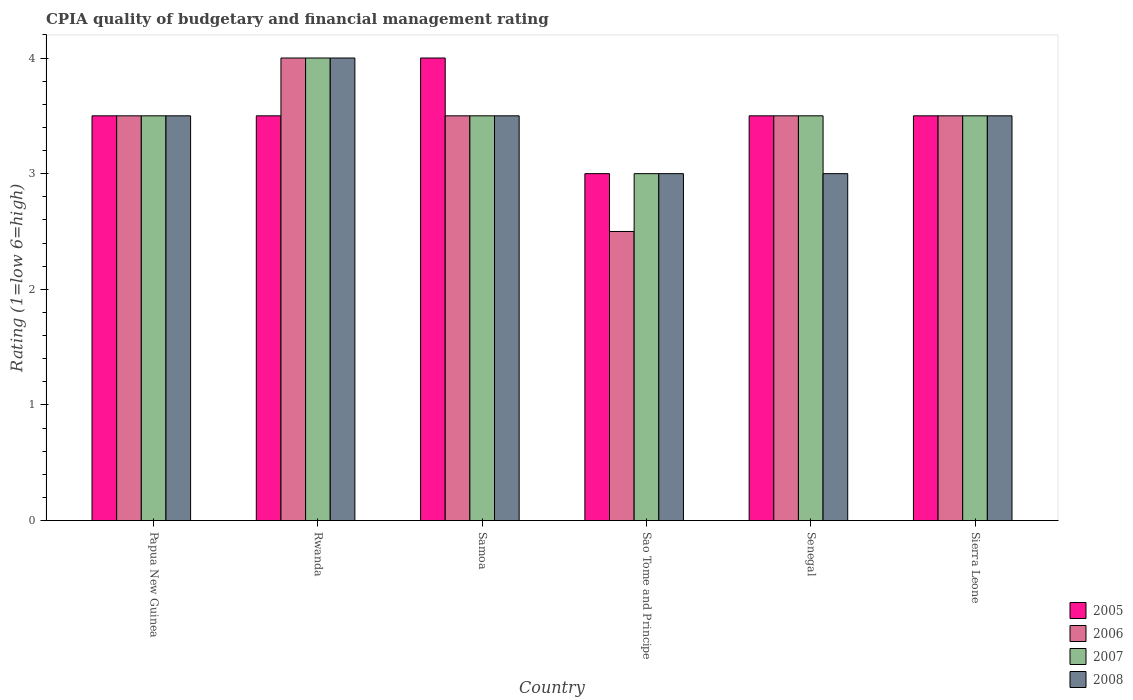How many groups of bars are there?
Offer a very short reply. 6. How many bars are there on the 3rd tick from the left?
Keep it short and to the point. 4. How many bars are there on the 6th tick from the right?
Your answer should be very brief. 4. What is the label of the 1st group of bars from the left?
Your answer should be very brief. Papua New Guinea. What is the CPIA rating in 2007 in Senegal?
Make the answer very short. 3.5. Across all countries, what is the minimum CPIA rating in 2008?
Offer a terse response. 3. In which country was the CPIA rating in 2007 maximum?
Ensure brevity in your answer.  Rwanda. In which country was the CPIA rating in 2006 minimum?
Provide a succinct answer. Sao Tome and Principe. In how many countries, is the CPIA rating in 2005 greater than 2.8?
Your answer should be compact. 6. What is the ratio of the CPIA rating in 2008 in Papua New Guinea to that in Samoa?
Make the answer very short. 1. Is the CPIA rating in 2005 in Papua New Guinea less than that in Senegal?
Provide a short and direct response. No. Is the difference between the CPIA rating in 2005 in Samoa and Sao Tome and Principe greater than the difference between the CPIA rating in 2007 in Samoa and Sao Tome and Principe?
Your answer should be compact. Yes. In how many countries, is the CPIA rating in 2005 greater than the average CPIA rating in 2005 taken over all countries?
Your answer should be compact. 1. Is it the case that in every country, the sum of the CPIA rating in 2006 and CPIA rating in 2005 is greater than the sum of CPIA rating in 2008 and CPIA rating in 2007?
Ensure brevity in your answer.  No. How many bars are there?
Make the answer very short. 24. How many countries are there in the graph?
Give a very brief answer. 6. What is the difference between two consecutive major ticks on the Y-axis?
Your response must be concise. 1. Does the graph contain grids?
Make the answer very short. No. How many legend labels are there?
Offer a very short reply. 4. How are the legend labels stacked?
Make the answer very short. Vertical. What is the title of the graph?
Make the answer very short. CPIA quality of budgetary and financial management rating. What is the label or title of the X-axis?
Your response must be concise. Country. What is the Rating (1=low 6=high) of 2005 in Papua New Guinea?
Your answer should be very brief. 3.5. What is the Rating (1=low 6=high) of 2006 in Papua New Guinea?
Give a very brief answer. 3.5. What is the Rating (1=low 6=high) in 2007 in Papua New Guinea?
Provide a short and direct response. 3.5. What is the Rating (1=low 6=high) in 2007 in Rwanda?
Your response must be concise. 4. What is the Rating (1=low 6=high) of 2008 in Rwanda?
Keep it short and to the point. 4. What is the Rating (1=low 6=high) in 2006 in Samoa?
Make the answer very short. 3.5. What is the Rating (1=low 6=high) in 2007 in Samoa?
Your answer should be compact. 3.5. What is the Rating (1=low 6=high) in 2008 in Samoa?
Make the answer very short. 3.5. What is the Rating (1=low 6=high) of 2005 in Sao Tome and Principe?
Your answer should be compact. 3. What is the Rating (1=low 6=high) in 2006 in Sao Tome and Principe?
Offer a very short reply. 2.5. What is the Rating (1=low 6=high) of 2008 in Sao Tome and Principe?
Your response must be concise. 3. What is the Rating (1=low 6=high) in 2007 in Senegal?
Your response must be concise. 3.5. What is the Rating (1=low 6=high) in 2008 in Senegal?
Provide a succinct answer. 3. What is the Rating (1=low 6=high) of 2007 in Sierra Leone?
Offer a very short reply. 3.5. What is the Rating (1=low 6=high) in 2008 in Sierra Leone?
Offer a terse response. 3.5. Across all countries, what is the maximum Rating (1=low 6=high) in 2005?
Your answer should be compact. 4. Across all countries, what is the maximum Rating (1=low 6=high) of 2006?
Your answer should be very brief. 4. Across all countries, what is the maximum Rating (1=low 6=high) in 2008?
Offer a very short reply. 4. Across all countries, what is the minimum Rating (1=low 6=high) of 2007?
Your response must be concise. 3. What is the total Rating (1=low 6=high) in 2006 in the graph?
Your answer should be very brief. 20.5. What is the difference between the Rating (1=low 6=high) in 2006 in Papua New Guinea and that in Rwanda?
Ensure brevity in your answer.  -0.5. What is the difference between the Rating (1=low 6=high) of 2008 in Papua New Guinea and that in Rwanda?
Keep it short and to the point. -0.5. What is the difference between the Rating (1=low 6=high) in 2008 in Papua New Guinea and that in Samoa?
Offer a terse response. 0. What is the difference between the Rating (1=low 6=high) in 2005 in Papua New Guinea and that in Sao Tome and Principe?
Your answer should be compact. 0.5. What is the difference between the Rating (1=low 6=high) in 2006 in Papua New Guinea and that in Sao Tome and Principe?
Your response must be concise. 1. What is the difference between the Rating (1=low 6=high) of 2007 in Papua New Guinea and that in Sao Tome and Principe?
Offer a very short reply. 0.5. What is the difference between the Rating (1=low 6=high) in 2008 in Papua New Guinea and that in Sao Tome and Principe?
Offer a very short reply. 0.5. What is the difference between the Rating (1=low 6=high) in 2007 in Papua New Guinea and that in Senegal?
Ensure brevity in your answer.  0. What is the difference between the Rating (1=low 6=high) in 2008 in Papua New Guinea and that in Senegal?
Your response must be concise. 0.5. What is the difference between the Rating (1=low 6=high) in 2006 in Papua New Guinea and that in Sierra Leone?
Your answer should be compact. 0. What is the difference between the Rating (1=low 6=high) of 2007 in Papua New Guinea and that in Sierra Leone?
Keep it short and to the point. 0. What is the difference between the Rating (1=low 6=high) in 2007 in Rwanda and that in Samoa?
Provide a succinct answer. 0.5. What is the difference between the Rating (1=low 6=high) of 2005 in Rwanda and that in Sao Tome and Principe?
Make the answer very short. 0.5. What is the difference between the Rating (1=low 6=high) in 2007 in Rwanda and that in Sao Tome and Principe?
Your answer should be compact. 1. What is the difference between the Rating (1=low 6=high) in 2008 in Rwanda and that in Sao Tome and Principe?
Your answer should be very brief. 1. What is the difference between the Rating (1=low 6=high) of 2006 in Rwanda and that in Senegal?
Make the answer very short. 0.5. What is the difference between the Rating (1=low 6=high) of 2007 in Rwanda and that in Senegal?
Keep it short and to the point. 0.5. What is the difference between the Rating (1=low 6=high) in 2006 in Rwanda and that in Sierra Leone?
Your answer should be very brief. 0.5. What is the difference between the Rating (1=low 6=high) in 2007 in Rwanda and that in Sierra Leone?
Your answer should be compact. 0.5. What is the difference between the Rating (1=low 6=high) in 2008 in Rwanda and that in Sierra Leone?
Your answer should be very brief. 0.5. What is the difference between the Rating (1=low 6=high) of 2005 in Samoa and that in Sao Tome and Principe?
Offer a terse response. 1. What is the difference between the Rating (1=low 6=high) of 2008 in Samoa and that in Sao Tome and Principe?
Your answer should be compact. 0.5. What is the difference between the Rating (1=low 6=high) in 2006 in Samoa and that in Senegal?
Your response must be concise. 0. What is the difference between the Rating (1=low 6=high) in 2007 in Samoa and that in Senegal?
Your answer should be very brief. 0. What is the difference between the Rating (1=low 6=high) of 2005 in Samoa and that in Sierra Leone?
Make the answer very short. 0.5. What is the difference between the Rating (1=low 6=high) of 2006 in Samoa and that in Sierra Leone?
Ensure brevity in your answer.  0. What is the difference between the Rating (1=low 6=high) in 2007 in Samoa and that in Sierra Leone?
Provide a short and direct response. 0. What is the difference between the Rating (1=low 6=high) of 2008 in Samoa and that in Sierra Leone?
Keep it short and to the point. 0. What is the difference between the Rating (1=low 6=high) in 2005 in Sao Tome and Principe and that in Senegal?
Keep it short and to the point. -0.5. What is the difference between the Rating (1=low 6=high) of 2008 in Sao Tome and Principe and that in Senegal?
Give a very brief answer. 0. What is the difference between the Rating (1=low 6=high) of 2006 in Sao Tome and Principe and that in Sierra Leone?
Your response must be concise. -1. What is the difference between the Rating (1=low 6=high) in 2008 in Sao Tome and Principe and that in Sierra Leone?
Offer a very short reply. -0.5. What is the difference between the Rating (1=low 6=high) in 2005 in Papua New Guinea and the Rating (1=low 6=high) in 2006 in Rwanda?
Provide a succinct answer. -0.5. What is the difference between the Rating (1=low 6=high) of 2007 in Papua New Guinea and the Rating (1=low 6=high) of 2008 in Rwanda?
Give a very brief answer. -0.5. What is the difference between the Rating (1=low 6=high) of 2006 in Papua New Guinea and the Rating (1=low 6=high) of 2007 in Samoa?
Make the answer very short. 0. What is the difference between the Rating (1=low 6=high) in 2006 in Papua New Guinea and the Rating (1=low 6=high) in 2008 in Samoa?
Give a very brief answer. 0. What is the difference between the Rating (1=low 6=high) of 2005 in Papua New Guinea and the Rating (1=low 6=high) of 2007 in Sao Tome and Principe?
Your response must be concise. 0.5. What is the difference between the Rating (1=low 6=high) of 2005 in Papua New Guinea and the Rating (1=low 6=high) of 2008 in Sao Tome and Principe?
Offer a terse response. 0.5. What is the difference between the Rating (1=low 6=high) of 2006 in Papua New Guinea and the Rating (1=low 6=high) of 2007 in Sao Tome and Principe?
Give a very brief answer. 0.5. What is the difference between the Rating (1=low 6=high) of 2006 in Papua New Guinea and the Rating (1=low 6=high) of 2008 in Sao Tome and Principe?
Offer a terse response. 0.5. What is the difference between the Rating (1=low 6=high) in 2005 in Papua New Guinea and the Rating (1=low 6=high) in 2006 in Senegal?
Your answer should be very brief. 0. What is the difference between the Rating (1=low 6=high) in 2006 in Papua New Guinea and the Rating (1=low 6=high) in 2008 in Senegal?
Your answer should be compact. 0.5. What is the difference between the Rating (1=low 6=high) of 2007 in Papua New Guinea and the Rating (1=low 6=high) of 2008 in Senegal?
Offer a very short reply. 0.5. What is the difference between the Rating (1=low 6=high) in 2005 in Papua New Guinea and the Rating (1=low 6=high) in 2008 in Sierra Leone?
Your answer should be compact. 0. What is the difference between the Rating (1=low 6=high) in 2006 in Papua New Guinea and the Rating (1=low 6=high) in 2008 in Sierra Leone?
Give a very brief answer. 0. What is the difference between the Rating (1=low 6=high) in 2005 in Rwanda and the Rating (1=low 6=high) in 2006 in Samoa?
Keep it short and to the point. 0. What is the difference between the Rating (1=low 6=high) of 2005 in Rwanda and the Rating (1=low 6=high) of 2007 in Samoa?
Make the answer very short. 0. What is the difference between the Rating (1=low 6=high) in 2005 in Rwanda and the Rating (1=low 6=high) in 2008 in Samoa?
Keep it short and to the point. 0. What is the difference between the Rating (1=low 6=high) in 2006 in Rwanda and the Rating (1=low 6=high) in 2007 in Samoa?
Ensure brevity in your answer.  0.5. What is the difference between the Rating (1=low 6=high) in 2007 in Rwanda and the Rating (1=low 6=high) in 2008 in Samoa?
Your answer should be compact. 0.5. What is the difference between the Rating (1=low 6=high) of 2005 in Rwanda and the Rating (1=low 6=high) of 2007 in Sao Tome and Principe?
Your response must be concise. 0.5. What is the difference between the Rating (1=low 6=high) in 2006 in Rwanda and the Rating (1=low 6=high) in 2008 in Sao Tome and Principe?
Offer a very short reply. 1. What is the difference between the Rating (1=low 6=high) in 2005 in Rwanda and the Rating (1=low 6=high) in 2006 in Senegal?
Your answer should be very brief. 0. What is the difference between the Rating (1=low 6=high) of 2006 in Rwanda and the Rating (1=low 6=high) of 2007 in Senegal?
Your answer should be compact. 0.5. What is the difference between the Rating (1=low 6=high) in 2006 in Rwanda and the Rating (1=low 6=high) in 2008 in Senegal?
Your response must be concise. 1. What is the difference between the Rating (1=low 6=high) in 2005 in Rwanda and the Rating (1=low 6=high) in 2007 in Sierra Leone?
Your answer should be very brief. 0. What is the difference between the Rating (1=low 6=high) in 2005 in Samoa and the Rating (1=low 6=high) in 2007 in Sao Tome and Principe?
Your answer should be compact. 1. What is the difference between the Rating (1=low 6=high) in 2005 in Samoa and the Rating (1=low 6=high) in 2008 in Sao Tome and Principe?
Provide a short and direct response. 1. What is the difference between the Rating (1=low 6=high) in 2005 in Samoa and the Rating (1=low 6=high) in 2006 in Senegal?
Your answer should be very brief. 0.5. What is the difference between the Rating (1=low 6=high) of 2006 in Samoa and the Rating (1=low 6=high) of 2008 in Senegal?
Provide a succinct answer. 0.5. What is the difference between the Rating (1=low 6=high) in 2007 in Samoa and the Rating (1=low 6=high) in 2008 in Senegal?
Your answer should be very brief. 0.5. What is the difference between the Rating (1=low 6=high) in 2005 in Samoa and the Rating (1=low 6=high) in 2008 in Sierra Leone?
Your answer should be very brief. 0.5. What is the difference between the Rating (1=low 6=high) of 2006 in Samoa and the Rating (1=low 6=high) of 2008 in Sierra Leone?
Give a very brief answer. 0. What is the difference between the Rating (1=low 6=high) of 2005 in Sao Tome and Principe and the Rating (1=low 6=high) of 2006 in Senegal?
Provide a short and direct response. -0.5. What is the difference between the Rating (1=low 6=high) in 2005 in Sao Tome and Principe and the Rating (1=low 6=high) in 2007 in Senegal?
Your answer should be very brief. -0.5. What is the difference between the Rating (1=low 6=high) in 2006 in Sao Tome and Principe and the Rating (1=low 6=high) in 2007 in Senegal?
Ensure brevity in your answer.  -1. What is the difference between the Rating (1=low 6=high) in 2006 in Sao Tome and Principe and the Rating (1=low 6=high) in 2008 in Senegal?
Offer a terse response. -0.5. What is the difference between the Rating (1=low 6=high) of 2007 in Sao Tome and Principe and the Rating (1=low 6=high) of 2008 in Senegal?
Ensure brevity in your answer.  0. What is the difference between the Rating (1=low 6=high) of 2005 in Sao Tome and Principe and the Rating (1=low 6=high) of 2006 in Sierra Leone?
Make the answer very short. -0.5. What is the difference between the Rating (1=low 6=high) in 2006 in Sao Tome and Principe and the Rating (1=low 6=high) in 2007 in Sierra Leone?
Offer a terse response. -1. What is the difference between the Rating (1=low 6=high) in 2005 in Senegal and the Rating (1=low 6=high) in 2007 in Sierra Leone?
Ensure brevity in your answer.  0. What is the difference between the Rating (1=low 6=high) in 2006 in Senegal and the Rating (1=low 6=high) in 2007 in Sierra Leone?
Give a very brief answer. 0. What is the difference between the Rating (1=low 6=high) in 2006 in Senegal and the Rating (1=low 6=high) in 2008 in Sierra Leone?
Keep it short and to the point. 0. What is the difference between the Rating (1=low 6=high) in 2007 in Senegal and the Rating (1=low 6=high) in 2008 in Sierra Leone?
Offer a terse response. 0. What is the average Rating (1=low 6=high) of 2005 per country?
Ensure brevity in your answer.  3.5. What is the average Rating (1=low 6=high) of 2006 per country?
Give a very brief answer. 3.42. What is the average Rating (1=low 6=high) of 2008 per country?
Make the answer very short. 3.42. What is the difference between the Rating (1=low 6=high) of 2006 and Rating (1=low 6=high) of 2007 in Papua New Guinea?
Make the answer very short. 0. What is the difference between the Rating (1=low 6=high) in 2007 and Rating (1=low 6=high) in 2008 in Papua New Guinea?
Make the answer very short. 0. What is the difference between the Rating (1=low 6=high) in 2007 and Rating (1=low 6=high) in 2008 in Rwanda?
Ensure brevity in your answer.  0. What is the difference between the Rating (1=low 6=high) in 2005 and Rating (1=low 6=high) in 2006 in Samoa?
Give a very brief answer. 0.5. What is the difference between the Rating (1=low 6=high) in 2005 and Rating (1=low 6=high) in 2008 in Samoa?
Provide a short and direct response. 0.5. What is the difference between the Rating (1=low 6=high) in 2006 and Rating (1=low 6=high) in 2007 in Samoa?
Your response must be concise. 0. What is the difference between the Rating (1=low 6=high) of 2006 and Rating (1=low 6=high) of 2007 in Sao Tome and Principe?
Provide a succinct answer. -0.5. What is the difference between the Rating (1=low 6=high) of 2006 and Rating (1=low 6=high) of 2008 in Sao Tome and Principe?
Make the answer very short. -0.5. What is the difference between the Rating (1=low 6=high) of 2005 and Rating (1=low 6=high) of 2006 in Senegal?
Provide a short and direct response. 0. What is the difference between the Rating (1=low 6=high) in 2006 and Rating (1=low 6=high) in 2008 in Senegal?
Provide a short and direct response. 0.5. What is the difference between the Rating (1=low 6=high) in 2006 and Rating (1=low 6=high) in 2007 in Sierra Leone?
Give a very brief answer. 0. What is the difference between the Rating (1=low 6=high) of 2007 and Rating (1=low 6=high) of 2008 in Sierra Leone?
Offer a terse response. 0. What is the ratio of the Rating (1=low 6=high) in 2005 in Papua New Guinea to that in Rwanda?
Ensure brevity in your answer.  1. What is the ratio of the Rating (1=low 6=high) in 2006 in Papua New Guinea to that in Rwanda?
Offer a terse response. 0.88. What is the ratio of the Rating (1=low 6=high) of 2008 in Papua New Guinea to that in Rwanda?
Offer a terse response. 0.88. What is the ratio of the Rating (1=low 6=high) of 2006 in Papua New Guinea to that in Samoa?
Make the answer very short. 1. What is the ratio of the Rating (1=low 6=high) of 2007 in Papua New Guinea to that in Samoa?
Make the answer very short. 1. What is the ratio of the Rating (1=low 6=high) in 2008 in Papua New Guinea to that in Samoa?
Your response must be concise. 1. What is the ratio of the Rating (1=low 6=high) in 2006 in Papua New Guinea to that in Senegal?
Keep it short and to the point. 1. What is the ratio of the Rating (1=low 6=high) in 2007 in Papua New Guinea to that in Senegal?
Keep it short and to the point. 1. What is the ratio of the Rating (1=low 6=high) of 2008 in Papua New Guinea to that in Senegal?
Keep it short and to the point. 1.17. What is the ratio of the Rating (1=low 6=high) of 2005 in Papua New Guinea to that in Sierra Leone?
Offer a very short reply. 1. What is the ratio of the Rating (1=low 6=high) in 2006 in Papua New Guinea to that in Sierra Leone?
Make the answer very short. 1. What is the ratio of the Rating (1=low 6=high) in 2007 in Papua New Guinea to that in Sierra Leone?
Offer a very short reply. 1. What is the ratio of the Rating (1=low 6=high) in 2006 in Rwanda to that in Samoa?
Keep it short and to the point. 1.14. What is the ratio of the Rating (1=low 6=high) in 2005 in Rwanda to that in Sao Tome and Principe?
Keep it short and to the point. 1.17. What is the ratio of the Rating (1=low 6=high) in 2006 in Rwanda to that in Sao Tome and Principe?
Your answer should be very brief. 1.6. What is the ratio of the Rating (1=low 6=high) of 2007 in Rwanda to that in Senegal?
Keep it short and to the point. 1.14. What is the ratio of the Rating (1=low 6=high) in 2005 in Rwanda to that in Sierra Leone?
Ensure brevity in your answer.  1. What is the ratio of the Rating (1=low 6=high) in 2006 in Rwanda to that in Sierra Leone?
Make the answer very short. 1.14. What is the ratio of the Rating (1=low 6=high) in 2007 in Rwanda to that in Sierra Leone?
Ensure brevity in your answer.  1.14. What is the ratio of the Rating (1=low 6=high) in 2005 in Samoa to that in Sao Tome and Principe?
Make the answer very short. 1.33. What is the ratio of the Rating (1=low 6=high) in 2006 in Samoa to that in Sao Tome and Principe?
Give a very brief answer. 1.4. What is the ratio of the Rating (1=low 6=high) of 2008 in Samoa to that in Sao Tome and Principe?
Your answer should be very brief. 1.17. What is the ratio of the Rating (1=low 6=high) in 2006 in Samoa to that in Senegal?
Provide a succinct answer. 1. What is the ratio of the Rating (1=low 6=high) of 2007 in Samoa to that in Senegal?
Your answer should be very brief. 1. What is the ratio of the Rating (1=low 6=high) of 2008 in Samoa to that in Senegal?
Offer a terse response. 1.17. What is the ratio of the Rating (1=low 6=high) in 2008 in Samoa to that in Sierra Leone?
Offer a terse response. 1. What is the ratio of the Rating (1=low 6=high) in 2006 in Sao Tome and Principe to that in Senegal?
Your answer should be compact. 0.71. What is the ratio of the Rating (1=low 6=high) of 2008 in Sao Tome and Principe to that in Senegal?
Offer a very short reply. 1. What is the ratio of the Rating (1=low 6=high) of 2005 in Sao Tome and Principe to that in Sierra Leone?
Keep it short and to the point. 0.86. What is the ratio of the Rating (1=low 6=high) of 2006 in Sao Tome and Principe to that in Sierra Leone?
Give a very brief answer. 0.71. What is the ratio of the Rating (1=low 6=high) in 2007 in Sao Tome and Principe to that in Sierra Leone?
Your response must be concise. 0.86. What is the ratio of the Rating (1=low 6=high) in 2005 in Senegal to that in Sierra Leone?
Make the answer very short. 1. What is the ratio of the Rating (1=low 6=high) of 2006 in Senegal to that in Sierra Leone?
Your response must be concise. 1. What is the ratio of the Rating (1=low 6=high) in 2008 in Senegal to that in Sierra Leone?
Offer a very short reply. 0.86. What is the difference between the highest and the second highest Rating (1=low 6=high) in 2007?
Your answer should be compact. 0.5. What is the difference between the highest and the lowest Rating (1=low 6=high) in 2006?
Your answer should be very brief. 1.5. What is the difference between the highest and the lowest Rating (1=low 6=high) in 2007?
Give a very brief answer. 1. 